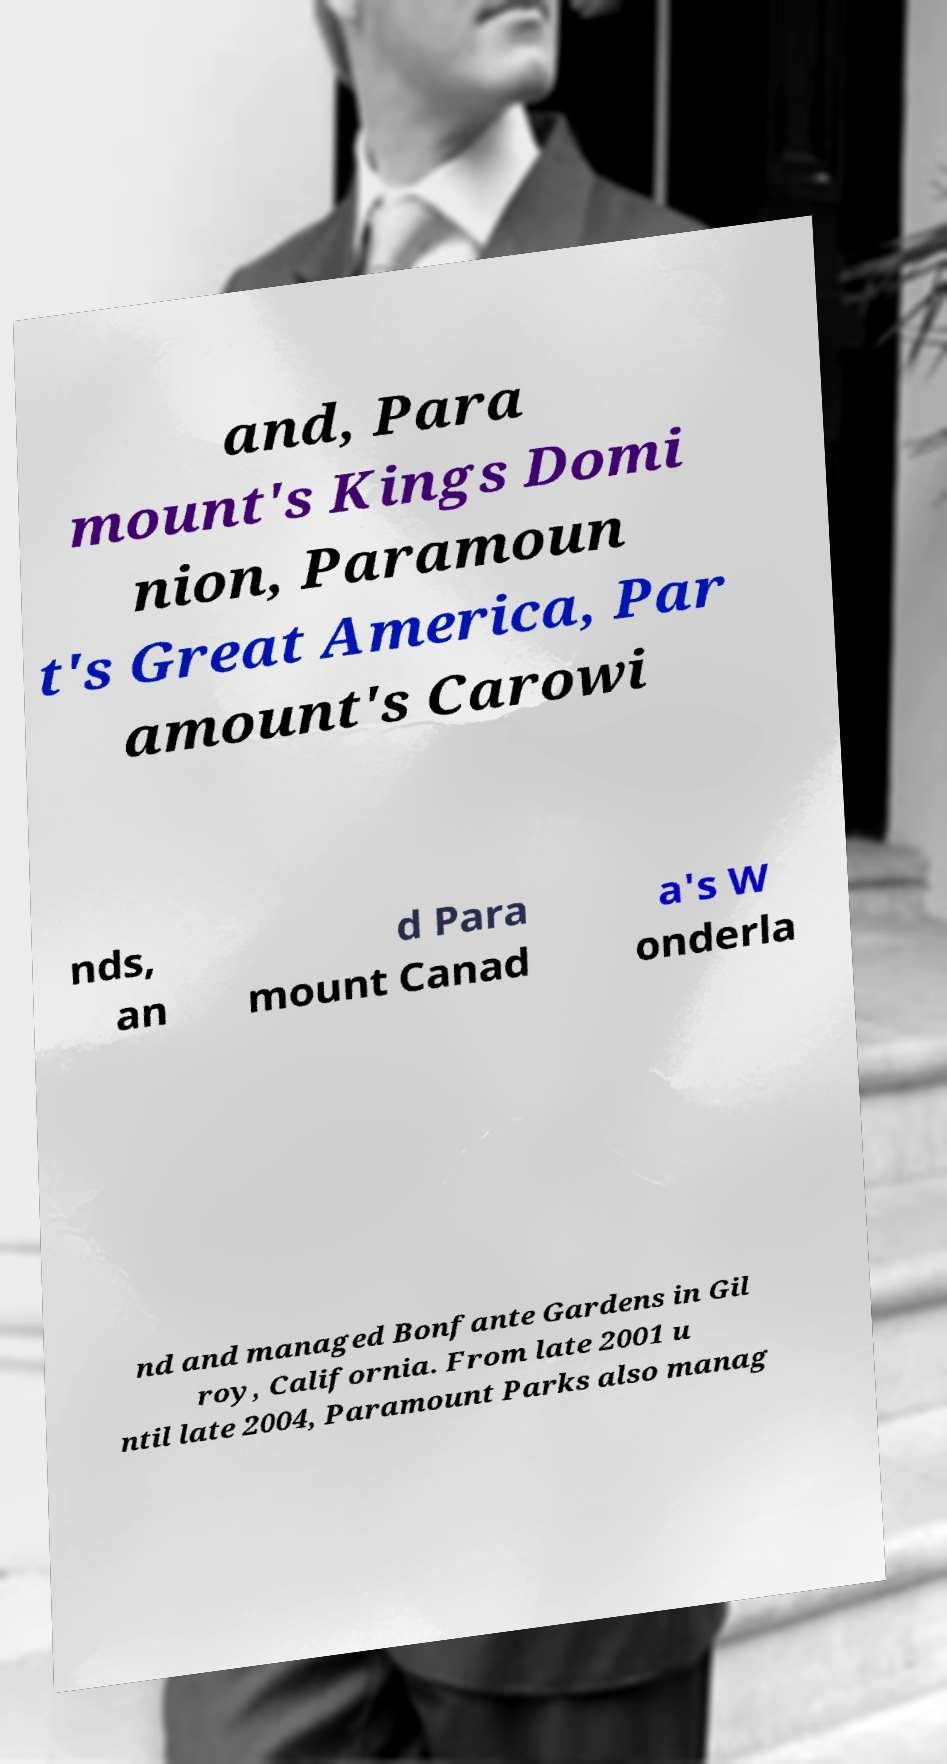For documentation purposes, I need the text within this image transcribed. Could you provide that? and, Para mount's Kings Domi nion, Paramoun t's Great America, Par amount's Carowi nds, an d Para mount Canad a's W onderla nd and managed Bonfante Gardens in Gil roy, California. From late 2001 u ntil late 2004, Paramount Parks also manag 